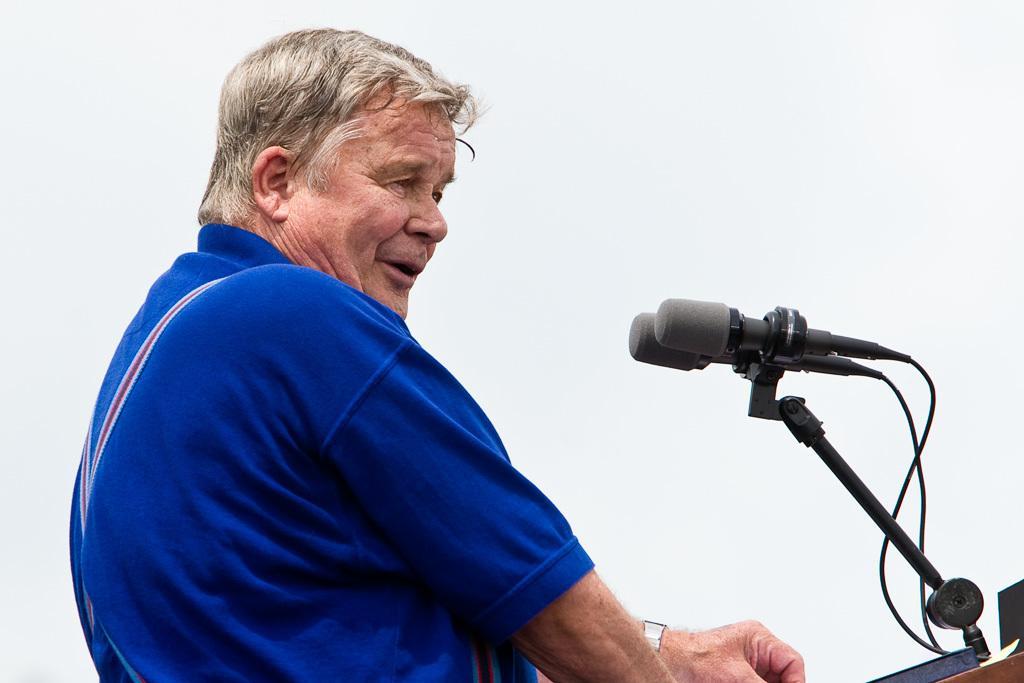Can you describe this image briefly? In this image I can see a man standing in-front of microphones. 